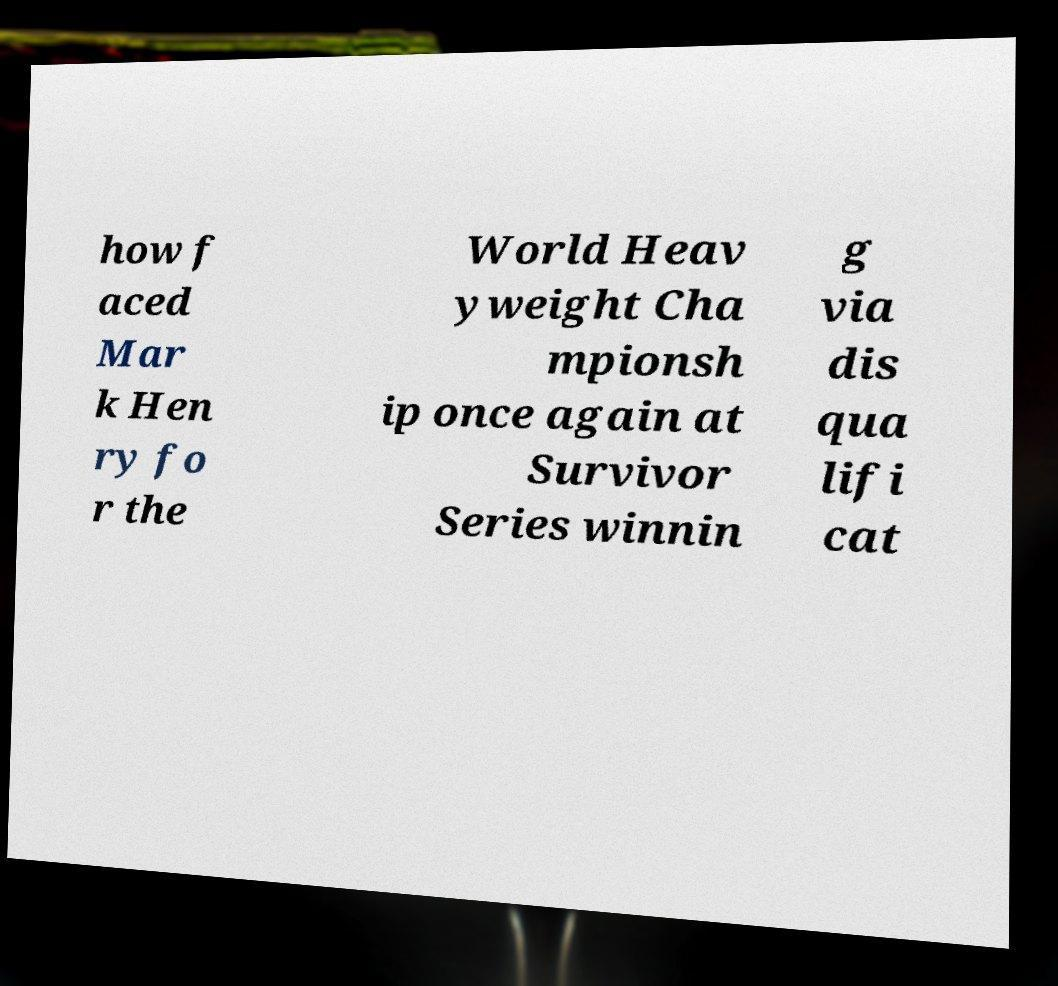Could you assist in decoding the text presented in this image and type it out clearly? how f aced Mar k Hen ry fo r the World Heav yweight Cha mpionsh ip once again at Survivor Series winnin g via dis qua lifi cat 